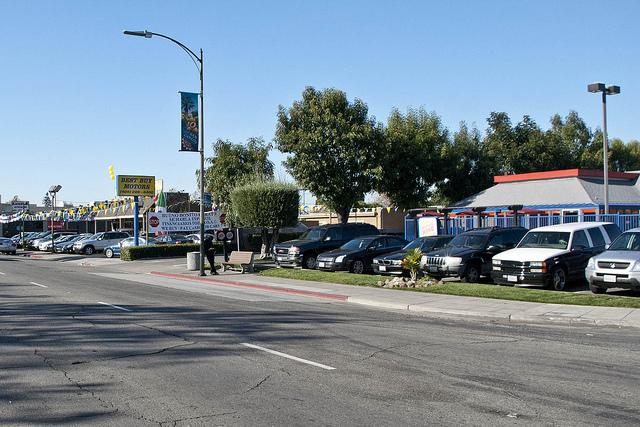What item does the business with banners in front of it sell?

Choices:
A) cars
B) nothing
C) car repair
D) milkshakes cars 